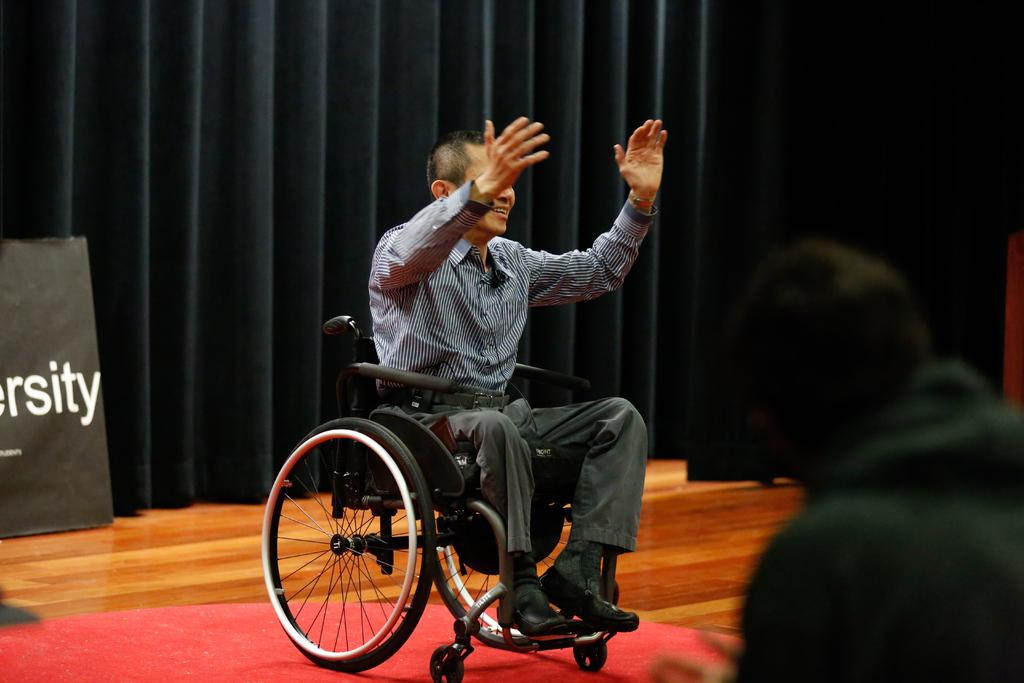What is the main subject of the image? There is a person sitting on a wheelchair in the image. What is the wheelchair placed on? The wheelchair is on a red carpet. Are there any other people in the image? Yes, there is another person standing in the image. What can be seen in the background of the image? There is a curtain visible in the background of the image. What type of quiver is the person holding in the image? There is no quiver present in the image. How many leaves can be seen on the person's head in the image? There are no leaves visible on anyone's head in the image. 